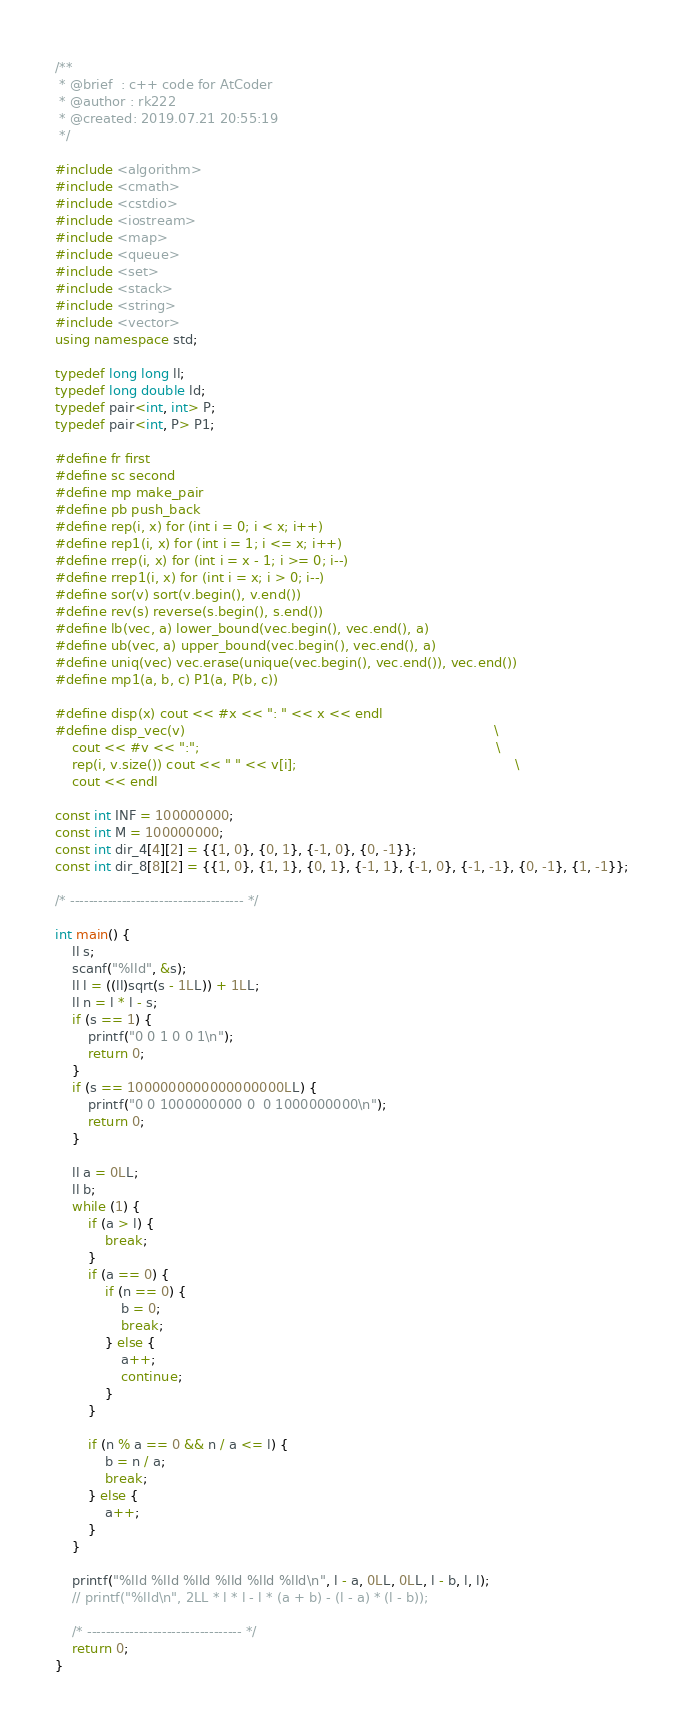Convert code to text. <code><loc_0><loc_0><loc_500><loc_500><_C++_>/**
 * @brief  : c++ code for AtCoder
 * @author : rk222
 * @created: 2019.07.21 20:55:19
 */

#include <algorithm>
#include <cmath>
#include <cstdio>
#include <iostream>
#include <map>
#include <queue>
#include <set>
#include <stack>
#include <string>
#include <vector>
using namespace std;

typedef long long ll;
typedef long double ld;
typedef pair<int, int> P;
typedef pair<int, P> P1;

#define fr first
#define sc second
#define mp make_pair
#define pb push_back
#define rep(i, x) for (int i = 0; i < x; i++)
#define rep1(i, x) for (int i = 1; i <= x; i++)
#define rrep(i, x) for (int i = x - 1; i >= 0; i--)
#define rrep1(i, x) for (int i = x; i > 0; i--)
#define sor(v) sort(v.begin(), v.end())
#define rev(s) reverse(s.begin(), s.end())
#define lb(vec, a) lower_bound(vec.begin(), vec.end(), a)
#define ub(vec, a) upper_bound(vec.begin(), vec.end(), a)
#define uniq(vec) vec.erase(unique(vec.begin(), vec.end()), vec.end())
#define mp1(a, b, c) P1(a, P(b, c))

#define disp(x) cout << #x << ": " << x << endl
#define disp_vec(v)                                                                           \
    cout << #v << ":";                                                                        \
    rep(i, v.size()) cout << " " << v[i];                                                     \
    cout << endl

const int INF = 100000000;
const int M = 100000000;
const int dir_4[4][2] = {{1, 0}, {0, 1}, {-1, 0}, {0, -1}};
const int dir_8[8][2] = {{1, 0}, {1, 1}, {0, 1}, {-1, 1}, {-1, 0}, {-1, -1}, {0, -1}, {1, -1}};

/* ------------------------------------- */

int main() {
    ll s;
    scanf("%lld", &s);
    ll l = ((ll)sqrt(s - 1LL)) + 1LL;
    ll n = l * l - s;
    if (s == 1) {
        printf("0 0 1 0 0 1\n");
        return 0;
    }
    if (s == 1000000000000000000LL) {
        printf("0 0 1000000000 0  0 1000000000\n");
        return 0;
    }

    ll a = 0LL;
    ll b;
    while (1) {
        if (a > l) {
            break;
        }
        if (a == 0) {
            if (n == 0) {
                b = 0;
                break;
            } else {
                a++;
                continue;
            }
        }

        if (n % a == 0 && n / a <= l) {
            b = n / a;
            break;
        } else {
            a++;
        }
    }

    printf("%lld %lld %lld %lld %lld %lld\n", l - a, 0LL, 0LL, l - b, l, l);
    // printf("%lld\n", 2LL * l * l - l * (a + b) - (l - a) * (l - b));

    /* --------------------------------- */
    return 0;
}</code> 